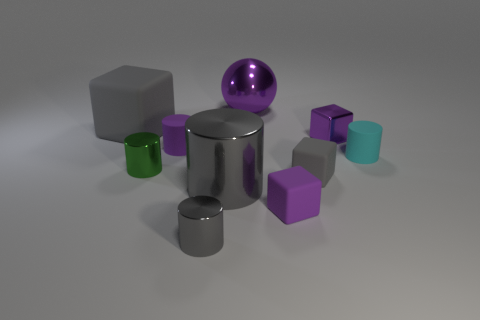How many large spheres are there?
Give a very brief answer. 1. There is another matte cylinder that is the same size as the purple cylinder; what is its color?
Ensure brevity in your answer.  Cyan. Do the green metallic object and the purple rubber cube have the same size?
Provide a succinct answer. Yes. The other large object that is the same color as the large rubber thing is what shape?
Offer a very short reply. Cylinder. There is a cyan rubber object; is its size the same as the purple matte thing that is to the right of the big purple sphere?
Give a very brief answer. Yes. There is a object that is in front of the large purple metal sphere and behind the tiny metallic cube; what color is it?
Your response must be concise. Gray. Is the number of big gray metallic cylinders that are behind the big purple metallic thing greater than the number of purple shiny blocks that are in front of the big metallic cylinder?
Ensure brevity in your answer.  No. What is the size of the cyan thing that is made of the same material as the large gray block?
Your answer should be compact. Small. There is a purple rubber thing that is to the left of the purple ball; what number of tiny gray rubber cubes are left of it?
Give a very brief answer. 0. Is there another large object that has the same shape as the green metal thing?
Make the answer very short. Yes. 